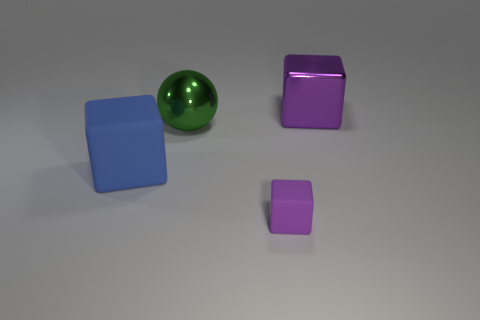Add 3 big green cylinders. How many objects exist? 7 Subtract all balls. How many objects are left? 3 Subtract 0 gray spheres. How many objects are left? 4 Subtract all big purple things. Subtract all small yellow cubes. How many objects are left? 3 Add 4 big green metal spheres. How many big green metal spheres are left? 5 Add 3 large matte things. How many large matte things exist? 4 